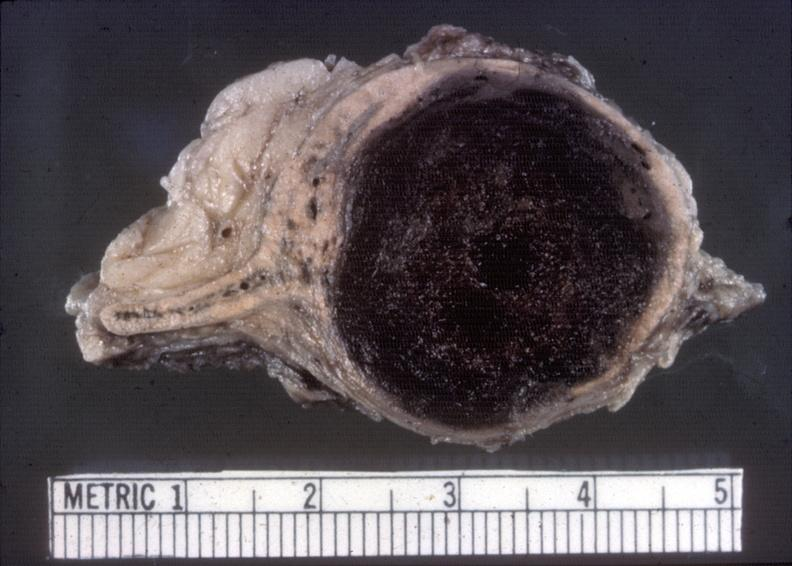does all the fat necrosis show adrenal, neuroblastoma?
Answer the question using a single word or phrase. No 